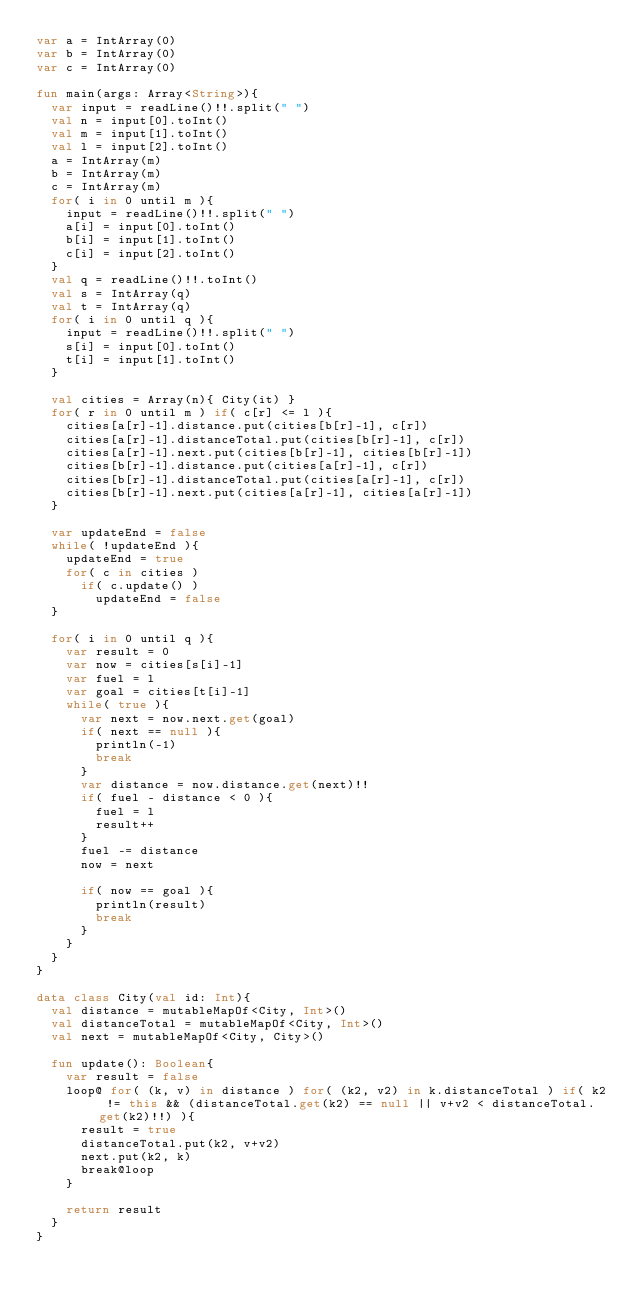<code> <loc_0><loc_0><loc_500><loc_500><_Kotlin_>var a = IntArray(0)
var b = IntArray(0)
var c = IntArray(0)

fun main(args: Array<String>){
  var input = readLine()!!.split(" ")
  val n = input[0].toInt()
  val m = input[1].toInt()
  val l = input[2].toInt()
  a = IntArray(m)
  b = IntArray(m)
  c = IntArray(m)
  for( i in 0 until m ){
    input = readLine()!!.split(" ")
    a[i] = input[0].toInt()
    b[i] = input[1].toInt()
    c[i] = input[2].toInt()
  }
  val q = readLine()!!.toInt()
  val s = IntArray(q)
  val t = IntArray(q)
  for( i in 0 until q ){
    input = readLine()!!.split(" ")
    s[i] = input[0].toInt()
    t[i] = input[1].toInt()
  }

  val cities = Array(n){ City(it) }
  for( r in 0 until m ) if( c[r] <= l ){
    cities[a[r]-1].distance.put(cities[b[r]-1], c[r])
    cities[a[r]-1].distanceTotal.put(cities[b[r]-1], c[r])
    cities[a[r]-1].next.put(cities[b[r]-1], cities[b[r]-1])
    cities[b[r]-1].distance.put(cities[a[r]-1], c[r])
    cities[b[r]-1].distanceTotal.put(cities[a[r]-1], c[r])
    cities[b[r]-1].next.put(cities[a[r]-1], cities[a[r]-1])
  }

  var updateEnd = false
  while( !updateEnd ){
    updateEnd = true
    for( c in cities )
      if( c.update() )
        updateEnd = false
  }

  for( i in 0 until q ){
    var result = 0
    var now = cities[s[i]-1]
    var fuel = l
    var goal = cities[t[i]-1]
    while( true ){
      var next = now.next.get(goal)
      if( next == null ){
        println(-1)
        break
      }
      var distance = now.distance.get(next)!!
      if( fuel - distance < 0 ){
        fuel = l
        result++
      }
      fuel -= distance
      now = next

      if( now == goal ){
        println(result)
        break
      }
    }
  }
}

data class City(val id: Int){
  val distance = mutableMapOf<City, Int>()
  val distanceTotal = mutableMapOf<City, Int>()
  val next = mutableMapOf<City, City>()

  fun update(): Boolean{
    var result = false
    loop@ for( (k, v) in distance ) for( (k2, v2) in k.distanceTotal ) if( k2 != this && (distanceTotal.get(k2) == null || v+v2 < distanceTotal.get(k2)!!) ){
      result = true
      distanceTotal.put(k2, v+v2)
      next.put(k2, k)
      break@loop
    }

    return result
  }
}
</code> 